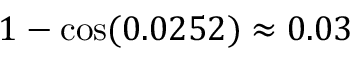<formula> <loc_0><loc_0><loc_500><loc_500>1 - \cos ( 0 . 0 2 5 2 ) \approx 0 . 0 3 \</formula> 